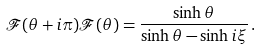Convert formula to latex. <formula><loc_0><loc_0><loc_500><loc_500>\mathcal { F } ( \theta + i \pi ) \mathcal { F } ( \theta ) = \frac { \sinh \theta } { \sinh \theta - \sinh i \xi } \, .</formula> 